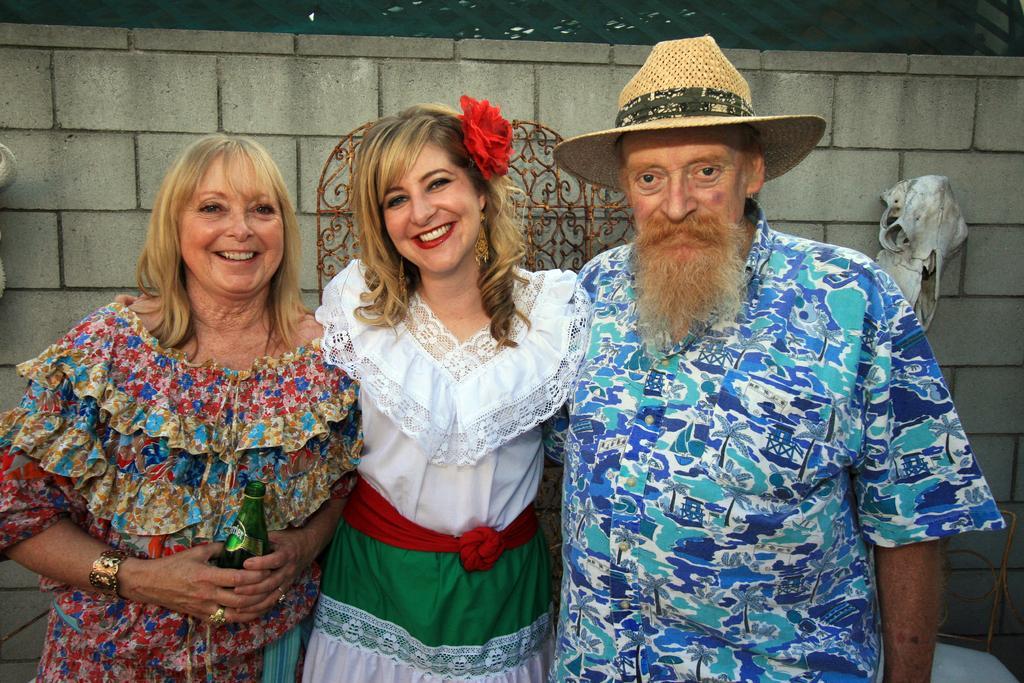Can you describe this image briefly? In this image I can see three persons are standing. I can see a person on the right is wearing a hat. In the background I can see the wall which is made up of bricks and to the wall I can see a white colored object and a brown colored metal object. 